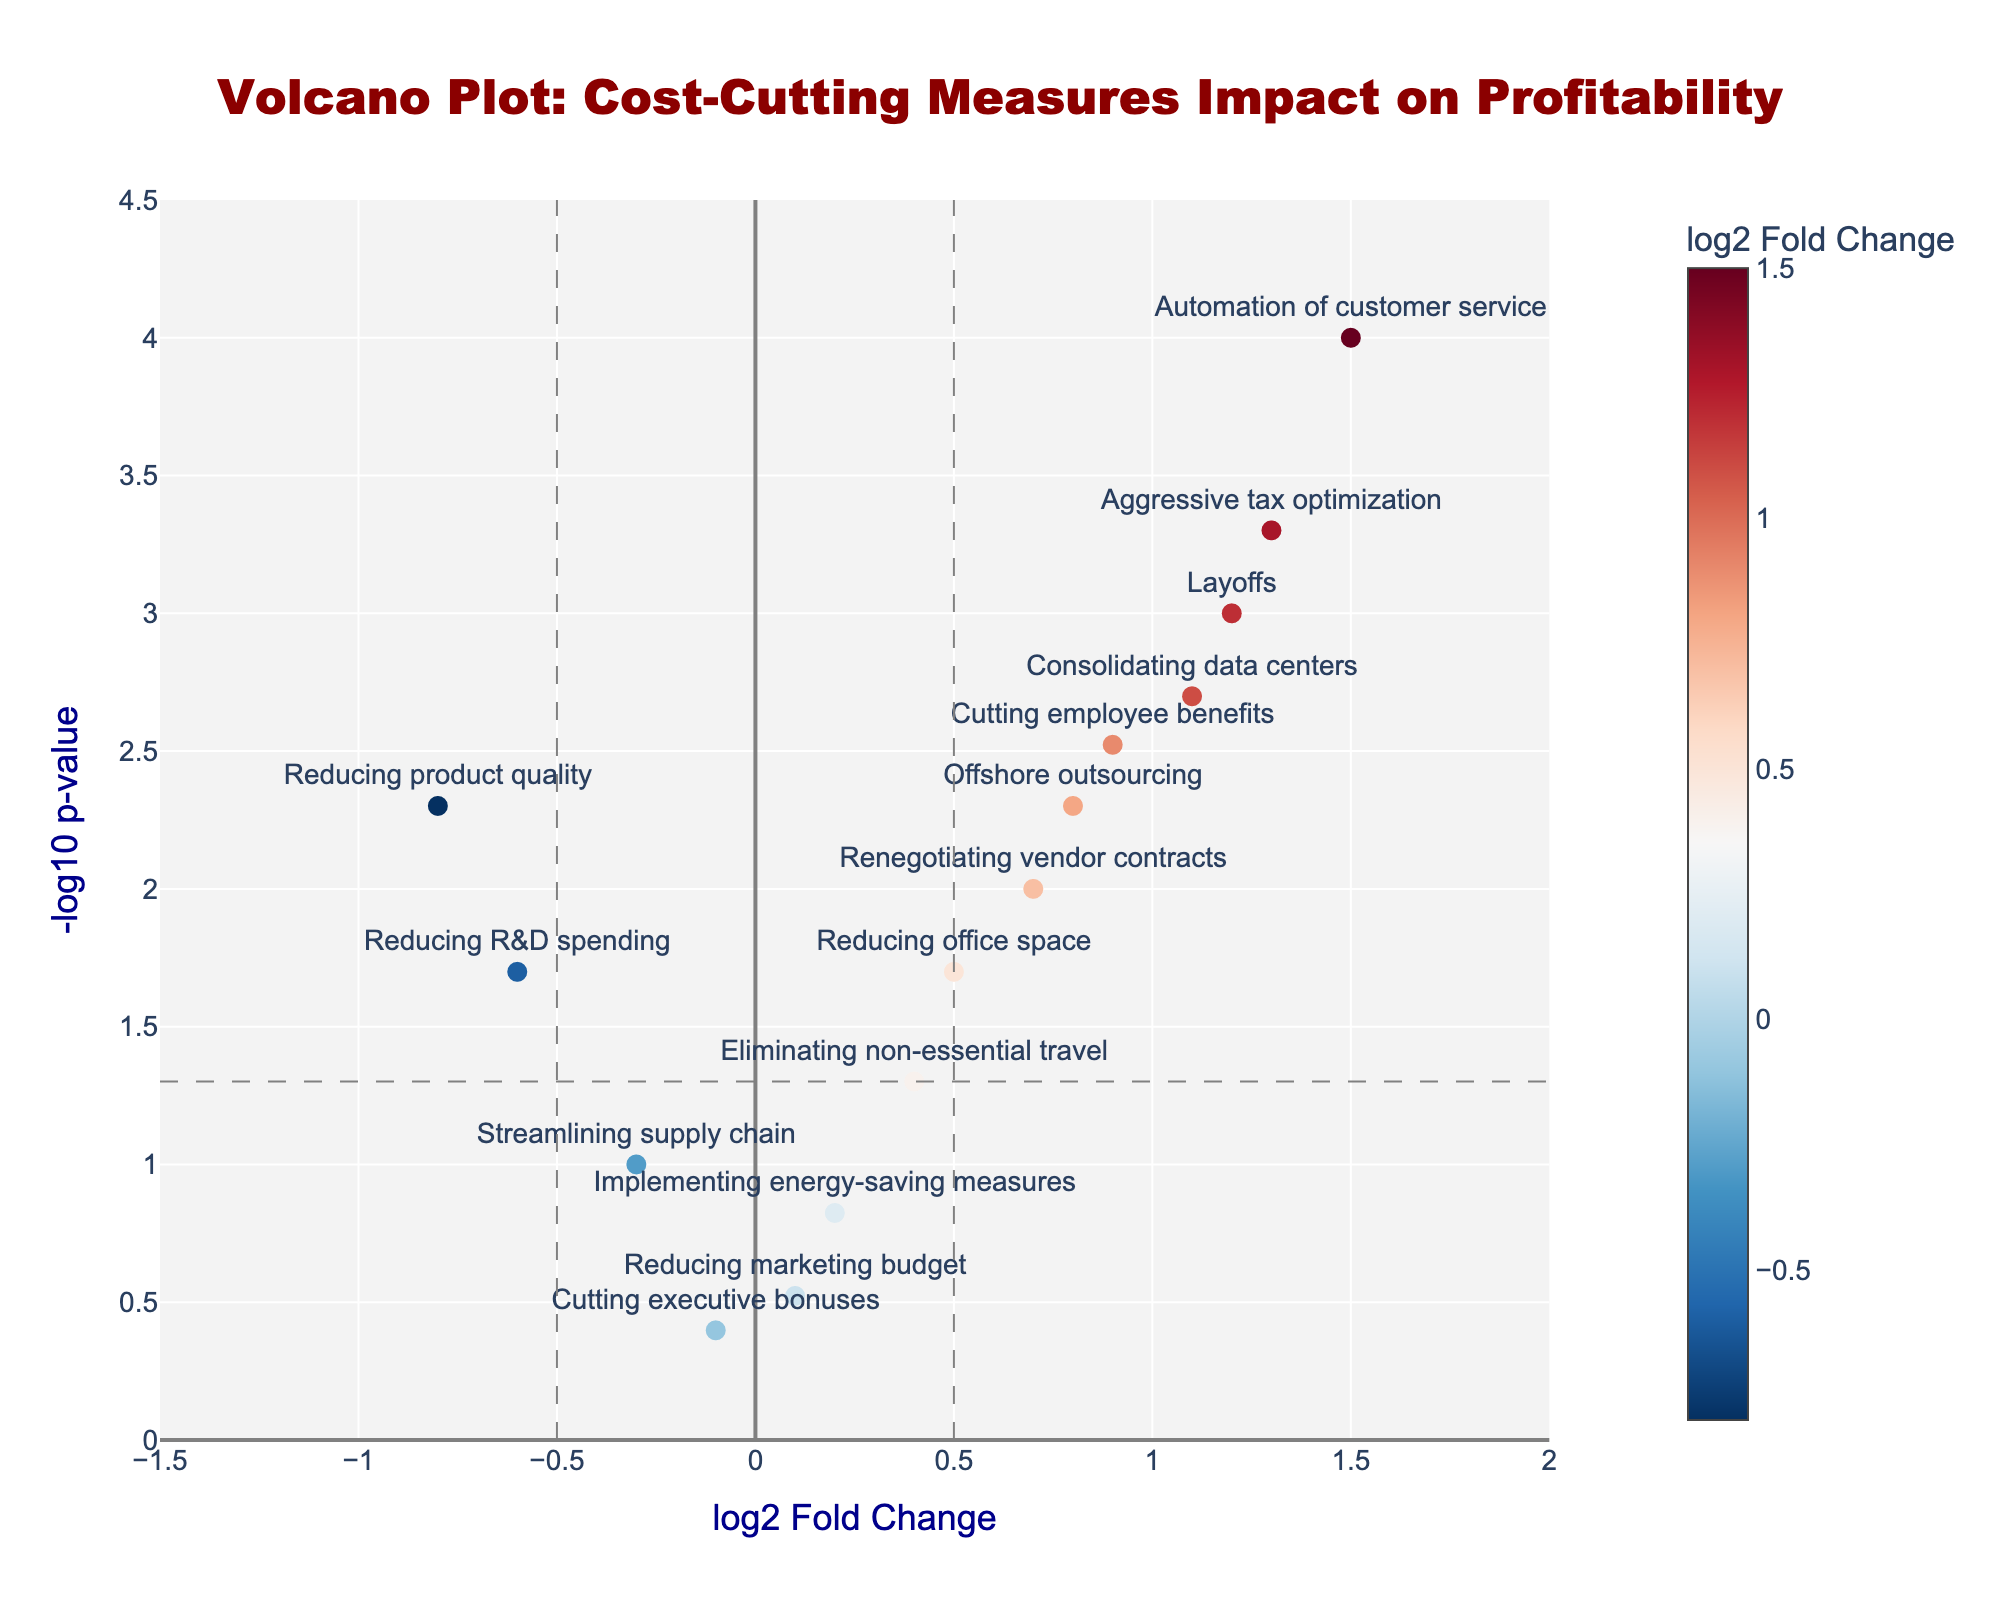What's the title of the figure? The title of the figure is displayed at the top of the plot in bold and large fonts.
Answer: Volcano Plot: Cost-Cutting Measures Impact on Profitability How many cost-cutting measures have a log2 fold change greater than 1? To determine this, count the data points to the right of the vertical line at log2 fold change equal to 1.
Answer: 3 Which cost-cutting measure has the smallest p-value? By checking which data point has the highest -log10(p-value), you can identify the measure with the smallest p-value.
Answer: Automation of customer service What is the log2 fold change and p-value of "Cutting employee benefits"? Read the x-axis (log2 fold change) and y-axis (p-value transformed to -log10) values associated with "Cutting employee benefits."
Answer: log2 fold change: 0.9, p-value: 0.003 Which measures have a negative log2 fold change? Look at data points to the left of zero on the x-axis for measures with negative log2 fold changes.
Answer: Streamlining supply chain, Reducing R&D spending, Reducing product quality, Cutting executive bonuses How many measures are statistically significant at p < 0.05? Identify the points above the horizontal line at -log10(0.05).
Answer: 9 How does the impact of "Aggressive tax optimization" compare to "Renegotiating vendor contracts"? Compare their positions on the plot: "Aggressive tax optimization" is higher on the y-axis and further right on the x-axis compared to "Renegotiating vendor contracts," meaning it has both a larger log2 fold change and smaller p-value.
Answer: Aggressive tax optimization has a larger impact and smaller p-value Which measure has the largest positive impact on overall company profitability? The measure with the highest log2 fold change to the right of the vertical line at 0 on the x-axis.
Answer: Automation of customer service What is the range of -log10(p-value) values shown in the plot? Look at the minimum and maximum values on the y-axis.
Answer: 0 to 4.5 Are there any cost-cutting measures that do not significantly impact profitability (p > 0.05)? If yes, name them. Look at the points below the horizontal line at -log10(0.05).
Answer: Reducing marketing budget, Implementing energy-saving measures, Streamlining supply chain, Cutting executive bonuses, Eliminating non-essential travel 